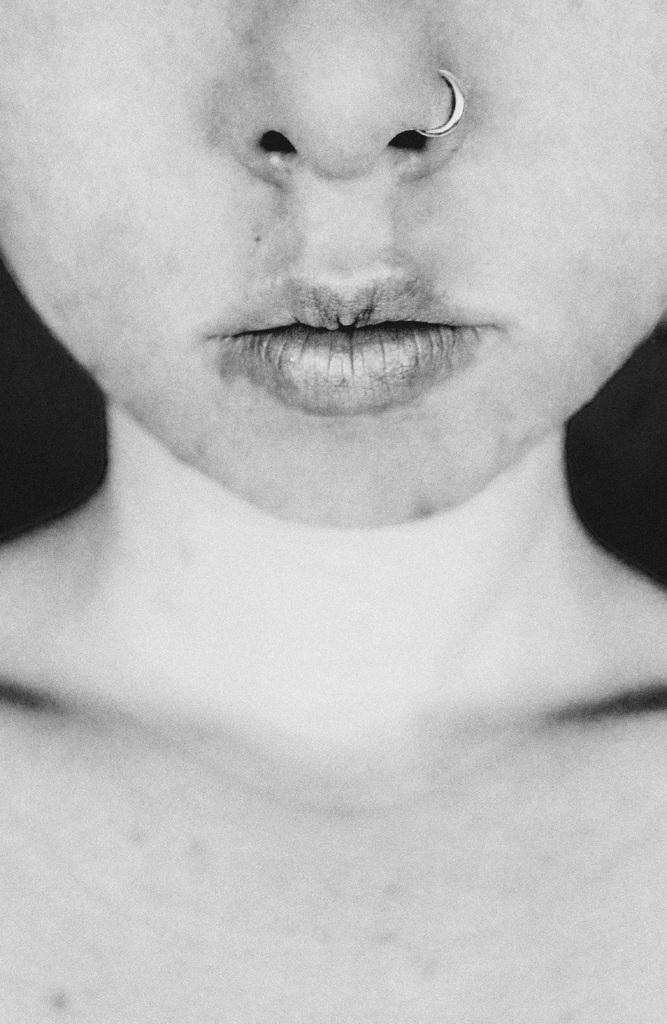What is the color scheme of the image? The image is black and white. What is the main subject of the image? The image features a person. Which facial features of the person are visible in the image? The person's neck, nose, lips, and cheeks are visible in the image. How would you describe the background of the image? The background of the image is dark. Can you see any mountains in the background of the image? There are no mountains visible in the background of the image; it is a black and white image featuring a person with a dark background. What type of pot is being used by the person in the image? There is no pot present in the image; it features a person with visible facial features and a dark background. 